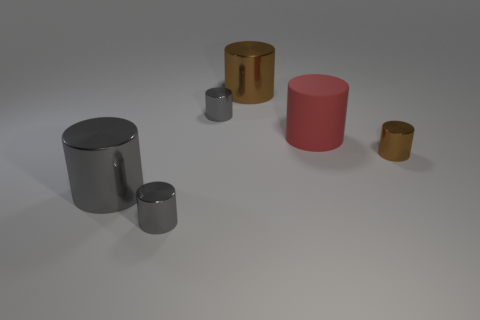How many things are large brown cylinders or rubber objects behind the tiny brown cylinder?
Provide a short and direct response. 2. There is a small brown object that is the same shape as the big gray shiny object; what is its material?
Keep it short and to the point. Metal. Is there any other thing that has the same size as the red rubber cylinder?
Offer a terse response. Yes. Is the number of big red matte things behind the red rubber cylinder less than the number of large metallic things behind the big brown object?
Provide a succinct answer. No. How many other things are there of the same shape as the small brown metal object?
Keep it short and to the point. 5. There is a brown metallic thing that is left of the tiny metal thing that is to the right of the gray shiny object that is behind the red rubber cylinder; what size is it?
Provide a succinct answer. Large. How many red things are metallic cylinders or large things?
Ensure brevity in your answer.  1. What shape is the tiny thing on the right side of the small gray thing behind the large red rubber thing?
Ensure brevity in your answer.  Cylinder. There is a brown object that is in front of the rubber cylinder; does it have the same size as the red object on the right side of the large gray metallic thing?
Your answer should be compact. No. Is there a tiny gray cylinder that has the same material as the big brown cylinder?
Your answer should be compact. Yes. 